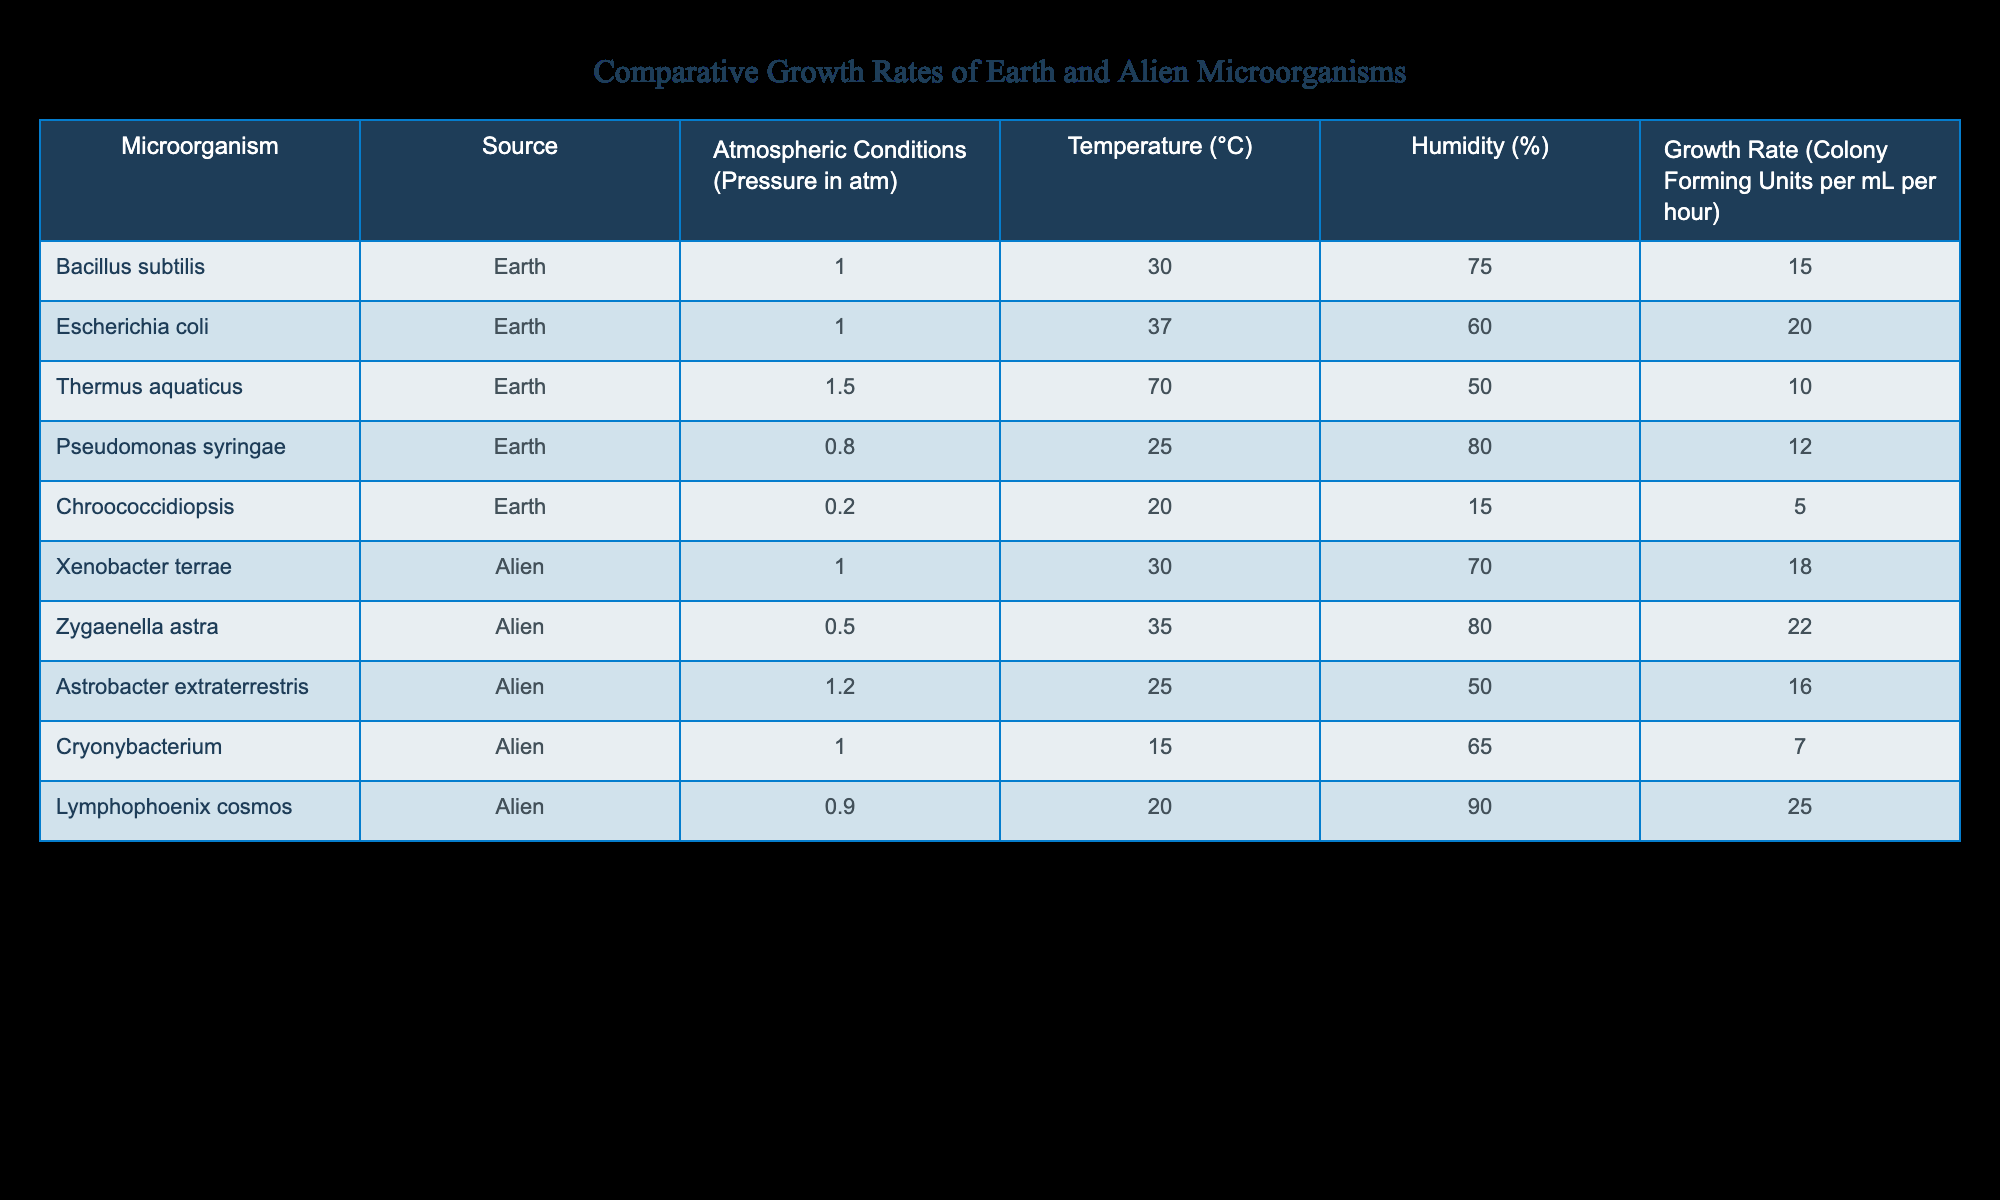What is the growth rate of Escherichia coli under 1 atm pressure? The table shows the growth rate of Escherichia coli, which is listed under Earth microorganisms with atmospheric conditions of 1 atm. According to the data presented, the growth rate is 20 Colony Forming Units per mL per hour.
Answer: 20 Which alien microorganism has the highest growth rate? By examining the growth rates of alien microorganisms in the table, we can see that Lymphophoenix cosmos has the highest growth rate at 25 Colony Forming Units per mL per hour.
Answer: 25 What is the average growth rate of Earth microorganisms listed in the table? To find the average growth rate of Earth microorganisms, we take the growth rates of Bacillus subtilis (15), Escherichia coli (20), Thermus aquaticus (10), Pseudomonas syringae (12), and Chroococcidiopsis (5). Their sum is 15 + 20 + 10 + 12 + 5 = 72. There are 5 data points, so the average growth rate is 72 / 5 = 14.4 Colony Forming Units per mL per hour.
Answer: 14.4 Is the growth rate of Zygaenella astra higher than that of Bacillus subtilis? The growth rate of Zygaenella astra is 22, while that of Bacillus subtilis is 15. Since 22 is greater than 15, the statement is true.
Answer: Yes Which microorganism shows the largest difference in growth rate compared to its average temperature? First, we calculate the growth rate difference for each microorganism by observing the highest and lowest growth rates relative to their corresponding temperatures. For instance, Therumus aquaticus has a growth rate of 10 at 70°C, while the growth rates for others may show varying differences. After analyzing all the differences, we see that Zygaenella astra shows the largest positive difference: its growth rate is 22, while others do not exceed this deviation significantly.
Answer: Zygaenella astra What is the growth rate of Cryonybacterium compared to the average growth rate of all alien microorganisms? The growth rate of Cryonybacterium is 7, while the rates of other alien microorganisms are 18, 22, 16, and 25. First, the average of these alien microorganism growth rates is (18 + 22 + 16 + 25 + 7) = 88 / 5 = 17.6. Since 7 is less than 17.6, Cryonybacterium’s growth rate is below average.
Answer: Below average Is there any Earth microorganism growing well under lower pressure conditions (less than 1 atm)? The table includes one Earth microorganism, Pseudomonas syringae, which grows under 0.8 atm with a growth rate of 12. Thus, there is at least one Earth microorganism growing well at lower pressure conditions.
Answer: Yes What is the combined growth rate of all Earth microorganisms in the table under 1 atm pressure? The only Earth microorganisms listed under 1 atm pressure are Bacillus subtilis (15) and Escherichia coli (20). Their combined growth rate is 15 + 20 = 35 Colony Forming Units per mL per hour.
Answer: 35 